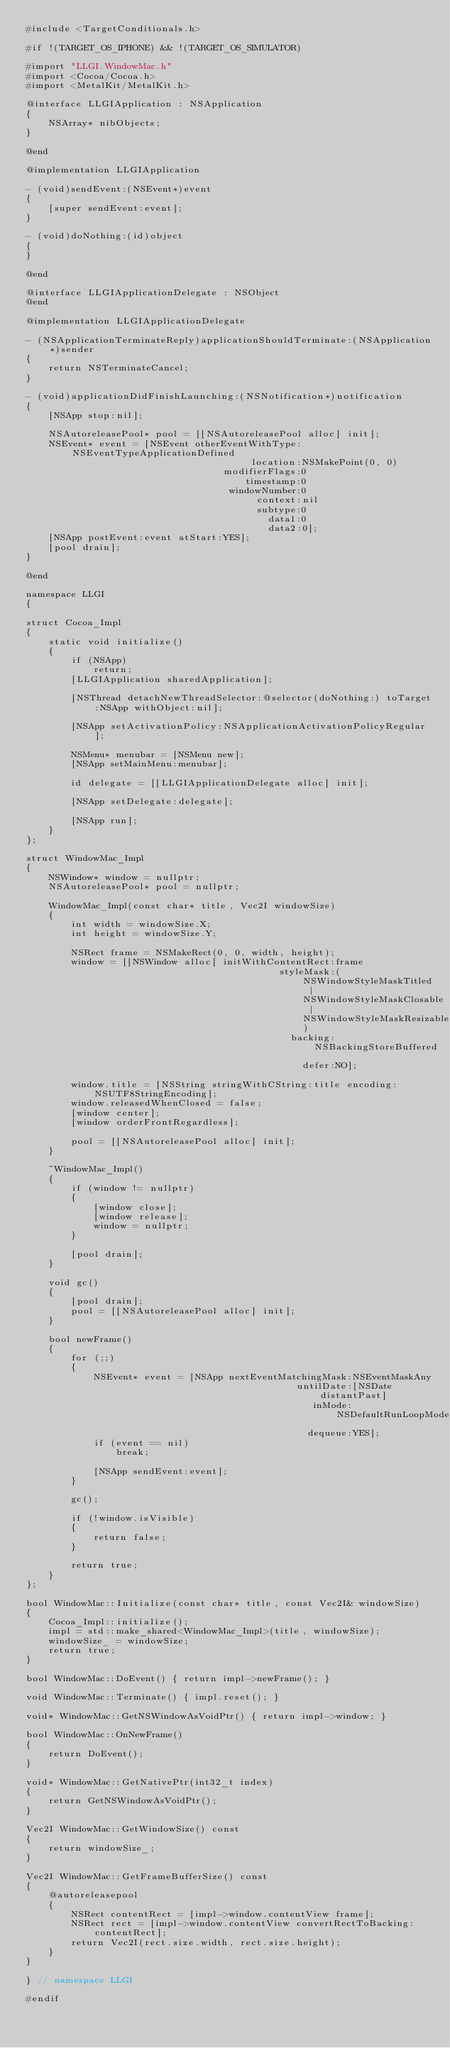Convert code to text. <code><loc_0><loc_0><loc_500><loc_500><_ObjectiveC_>#include <TargetConditionals.h>

#if !(TARGET_OS_IPHONE) && !(TARGET_OS_SIMULATOR)

#import "LLGI.WindowMac.h"
#import <Cocoa/Cocoa.h>
#import <MetalKit/MetalKit.h>

@interface LLGIApplication : NSApplication
{
	NSArray* nibObjects;
}

@end

@implementation LLGIApplication

- (void)sendEvent:(NSEvent*)event
{
	[super sendEvent:event];
}

- (void)doNothing:(id)object
{
}

@end

@interface LLGIApplicationDelegate : NSObject
@end

@implementation LLGIApplicationDelegate

- (NSApplicationTerminateReply)applicationShouldTerminate:(NSApplication*)sender
{
	return NSTerminateCancel;
}

- (void)applicationDidFinishLaunching:(NSNotification*)notification
{
	[NSApp stop:nil];

	NSAutoreleasePool* pool = [[NSAutoreleasePool alloc] init];
	NSEvent* event = [NSEvent otherEventWithType:NSEventTypeApplicationDefined
										location:NSMakePoint(0, 0)
								   modifierFlags:0
									   timestamp:0
									windowNumber:0
										 context:nil
										 subtype:0
										   data1:0
										   data2:0];
	[NSApp postEvent:event atStart:YES];
	[pool drain];
}

@end

namespace LLGI
{

struct Cocoa_Impl
{
	static void initialize()
	{
		if (NSApp)
			return;
		[LLGIApplication sharedApplication];

		[NSThread detachNewThreadSelector:@selector(doNothing:) toTarget:NSApp withObject:nil];

		[NSApp setActivationPolicy:NSApplicationActivationPolicyRegular];

		NSMenu* menubar = [NSMenu new];
		[NSApp setMainMenu:menubar];

		id delegate = [[LLGIApplicationDelegate alloc] init];

		[NSApp setDelegate:delegate];

		[NSApp run];
	}
};

struct WindowMac_Impl
{
	NSWindow* window = nullptr;
	NSAutoreleasePool* pool = nullptr;

	WindowMac_Impl(const char* title, Vec2I windowSize)
	{
		int width = windowSize.X;
		int height = windowSize.Y;

		NSRect frame = NSMakeRect(0, 0, width, height);
		window = [[NSWindow alloc] initWithContentRect:frame
											 styleMask:(NSWindowStyleMaskTitled | NSWindowStyleMaskClosable | NSWindowStyleMaskResizable)
											   backing:NSBackingStoreBuffered
												 defer:NO];

		window.title = [NSString stringWithCString:title encoding:NSUTF8StringEncoding];
		window.releasedWhenClosed = false;
		[window center];
		[window orderFrontRegardless];

		pool = [[NSAutoreleasePool alloc] init];
	}

	~WindowMac_Impl()
	{
		if (window != nullptr)
		{
            [window close];
			[window release];
			window = nullptr;
		}

		[pool drain];
	}

	void gc()
	{
		[pool drain];
		pool = [[NSAutoreleasePool alloc] init];
	}

	bool newFrame()
	{
		for (;;)
		{
			NSEvent* event = [NSApp nextEventMatchingMask:NSEventMaskAny
												untilDate:[NSDate distantPast]
												   inMode:NSDefaultRunLoopMode
												  dequeue:YES];
			if (event == nil)
				break;

			[NSApp sendEvent:event];
		}

		gc();

		if (!window.isVisible)
		{
			return false;
		}

		return true;
	}
};

bool WindowMac::Initialize(const char* title, const Vec2I& windowSize)
{
	Cocoa_Impl::initialize();
	impl = std::make_shared<WindowMac_Impl>(title, windowSize);
    windowSize_ = windowSize;
	return true;
}

bool WindowMac::DoEvent() { return impl->newFrame(); }

void WindowMac::Terminate() { impl.reset(); }

void* WindowMac::GetNSWindowAsVoidPtr() { return impl->window; }

bool WindowMac::OnNewFrame()
{
    return DoEvent();
}
    
void* WindowMac::GetNativePtr(int32_t index)
{
    return GetNSWindowAsVoidPtr();
}
    
Vec2I WindowMac::GetWindowSize() const
{
    return windowSize_;
}

Vec2I WindowMac::GetFrameBufferSize() const
{
    @autoreleasepool
    {
        NSRect contentRect = [impl->window.contentView frame];
        NSRect rect = [impl->window.contentView convertRectToBacking:contentRect];
        return Vec2I(rect.size.width, rect.size.height);
    }
}
    
} // namespace LLGI

#endif
</code> 